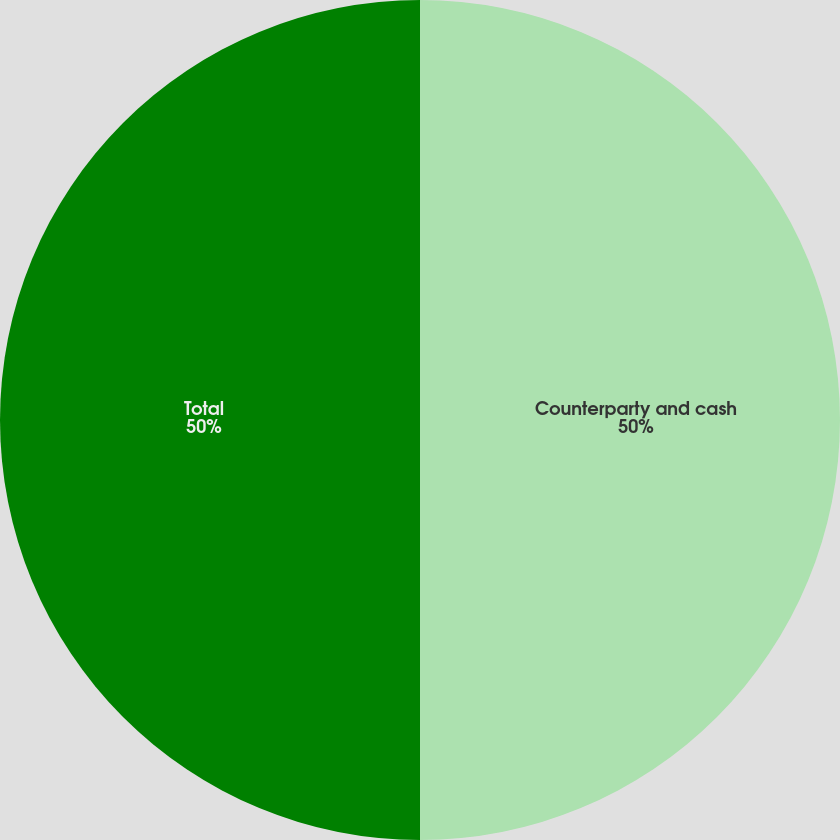Convert chart to OTSL. <chart><loc_0><loc_0><loc_500><loc_500><pie_chart><fcel>Counterparty and cash<fcel>Total<nl><fcel>50.0%<fcel>50.0%<nl></chart> 